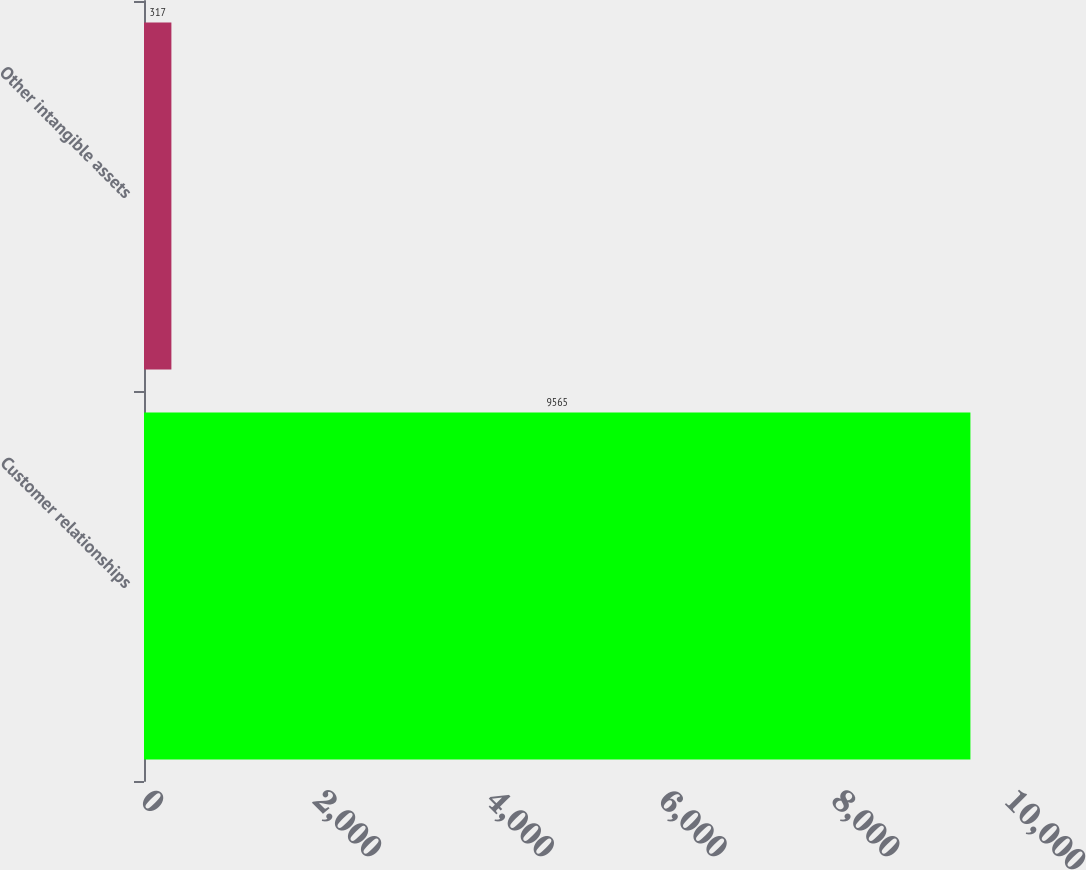Convert chart. <chart><loc_0><loc_0><loc_500><loc_500><bar_chart><fcel>Customer relationships<fcel>Other intangible assets<nl><fcel>9565<fcel>317<nl></chart> 